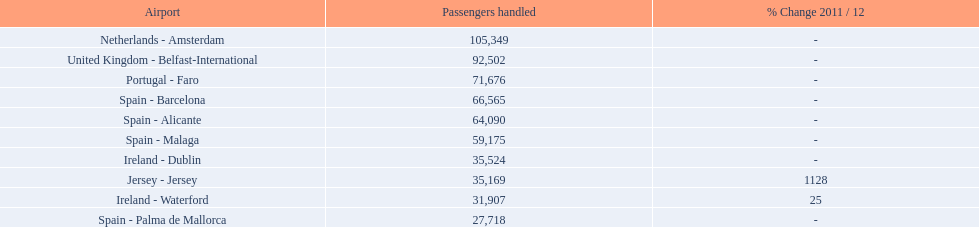What is the best rank? 1. Would you be able to parse every entry in this table? {'header': ['Airport', 'Passengers handled', '% Change 2011 / 12'], 'rows': [['Netherlands - Amsterdam', '105,349', '-'], ['United Kingdom - Belfast-International', '92,502', '-'], ['Portugal - Faro', '71,676', '-'], ['Spain - Barcelona', '66,565', '-'], ['Spain - Alicante', '64,090', '-'], ['Spain - Malaga', '59,175', '-'], ['Ireland - Dublin', '35,524', '-'], ['Jersey - Jersey', '35,169', '1128'], ['Ireland - Waterford', '31,907', '25'], ['Spain - Palma de Mallorca', '27,718', '-']]} What is the airport? Netherlands - Amsterdam. 